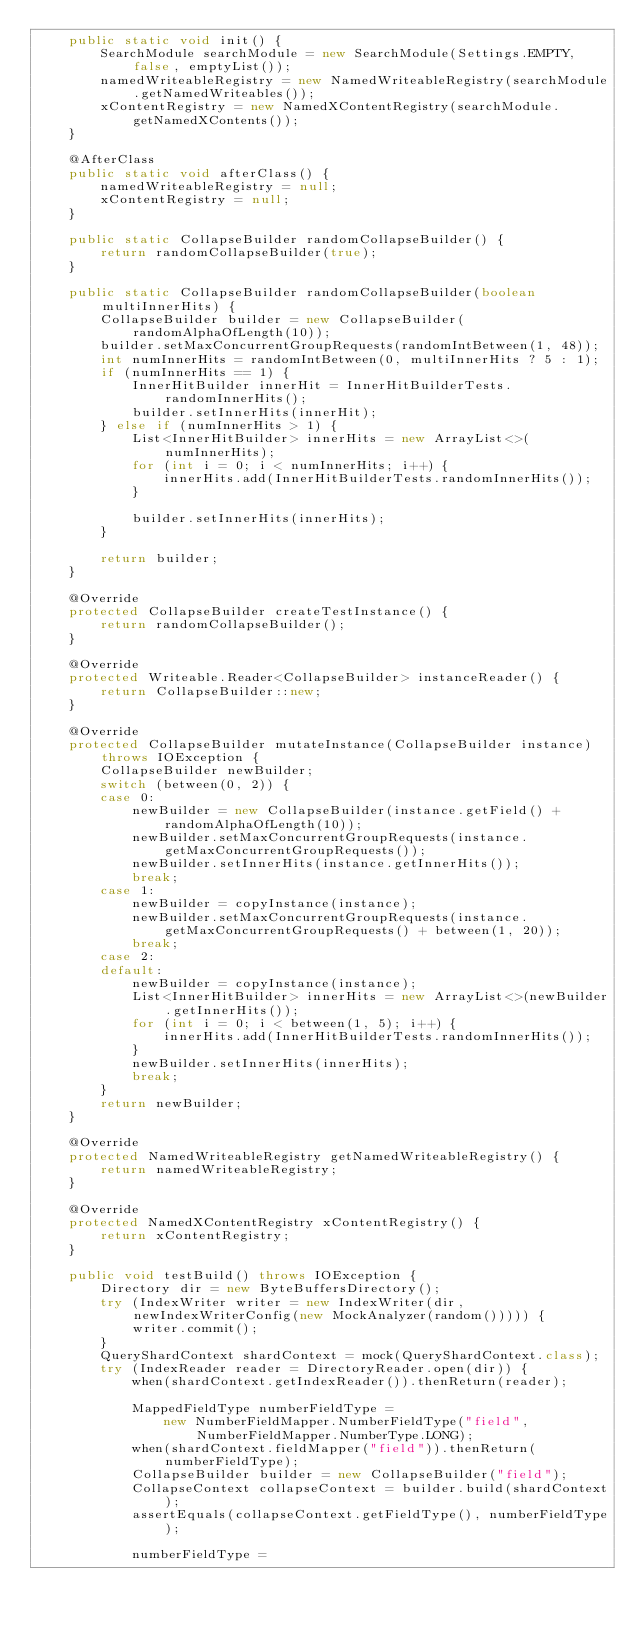Convert code to text. <code><loc_0><loc_0><loc_500><loc_500><_Java_>    public static void init() {
        SearchModule searchModule = new SearchModule(Settings.EMPTY, false, emptyList());
        namedWriteableRegistry = new NamedWriteableRegistry(searchModule.getNamedWriteables());
        xContentRegistry = new NamedXContentRegistry(searchModule.getNamedXContents());
    }

    @AfterClass
    public static void afterClass() {
        namedWriteableRegistry = null;
        xContentRegistry = null;
    }

    public static CollapseBuilder randomCollapseBuilder() {
        return randomCollapseBuilder(true);
    }

    public static CollapseBuilder randomCollapseBuilder(boolean multiInnerHits) {
        CollapseBuilder builder = new CollapseBuilder(randomAlphaOfLength(10));
        builder.setMaxConcurrentGroupRequests(randomIntBetween(1, 48));
        int numInnerHits = randomIntBetween(0, multiInnerHits ? 5 : 1);
        if (numInnerHits == 1) {
            InnerHitBuilder innerHit = InnerHitBuilderTests.randomInnerHits();
            builder.setInnerHits(innerHit);
        } else if (numInnerHits > 1) {
            List<InnerHitBuilder> innerHits = new ArrayList<>(numInnerHits);
            for (int i = 0; i < numInnerHits; i++) {
                innerHits.add(InnerHitBuilderTests.randomInnerHits());
            }

            builder.setInnerHits(innerHits);
        }

        return builder;
    }

    @Override
    protected CollapseBuilder createTestInstance() {
        return randomCollapseBuilder();
    }

    @Override
    protected Writeable.Reader<CollapseBuilder> instanceReader() {
        return CollapseBuilder::new;
    }

    @Override
    protected CollapseBuilder mutateInstance(CollapseBuilder instance) throws IOException {
        CollapseBuilder newBuilder;
        switch (between(0, 2)) {
        case 0:
            newBuilder = new CollapseBuilder(instance.getField() + randomAlphaOfLength(10));
            newBuilder.setMaxConcurrentGroupRequests(instance.getMaxConcurrentGroupRequests());
            newBuilder.setInnerHits(instance.getInnerHits());
            break;
        case 1:
            newBuilder = copyInstance(instance);
            newBuilder.setMaxConcurrentGroupRequests(instance.getMaxConcurrentGroupRequests() + between(1, 20));
            break;
        case 2:
        default:
            newBuilder = copyInstance(instance);
            List<InnerHitBuilder> innerHits = new ArrayList<>(newBuilder.getInnerHits());
            for (int i = 0; i < between(1, 5); i++) {
                innerHits.add(InnerHitBuilderTests.randomInnerHits());
            }
            newBuilder.setInnerHits(innerHits);
            break;
        }
        return newBuilder;
    }

    @Override
    protected NamedWriteableRegistry getNamedWriteableRegistry() {
        return namedWriteableRegistry;
    }

    @Override
    protected NamedXContentRegistry xContentRegistry() {
        return xContentRegistry;
    }

    public void testBuild() throws IOException {
        Directory dir = new ByteBuffersDirectory();
        try (IndexWriter writer = new IndexWriter(dir, newIndexWriterConfig(new MockAnalyzer(random())))) {
            writer.commit();
        }
        QueryShardContext shardContext = mock(QueryShardContext.class);
        try (IndexReader reader = DirectoryReader.open(dir)) {
            when(shardContext.getIndexReader()).thenReturn(reader);

            MappedFieldType numberFieldType =
                new NumberFieldMapper.NumberFieldType("field", NumberFieldMapper.NumberType.LONG);
            when(shardContext.fieldMapper("field")).thenReturn(numberFieldType);
            CollapseBuilder builder = new CollapseBuilder("field");
            CollapseContext collapseContext = builder.build(shardContext);
            assertEquals(collapseContext.getFieldType(), numberFieldType);

            numberFieldType =</code> 